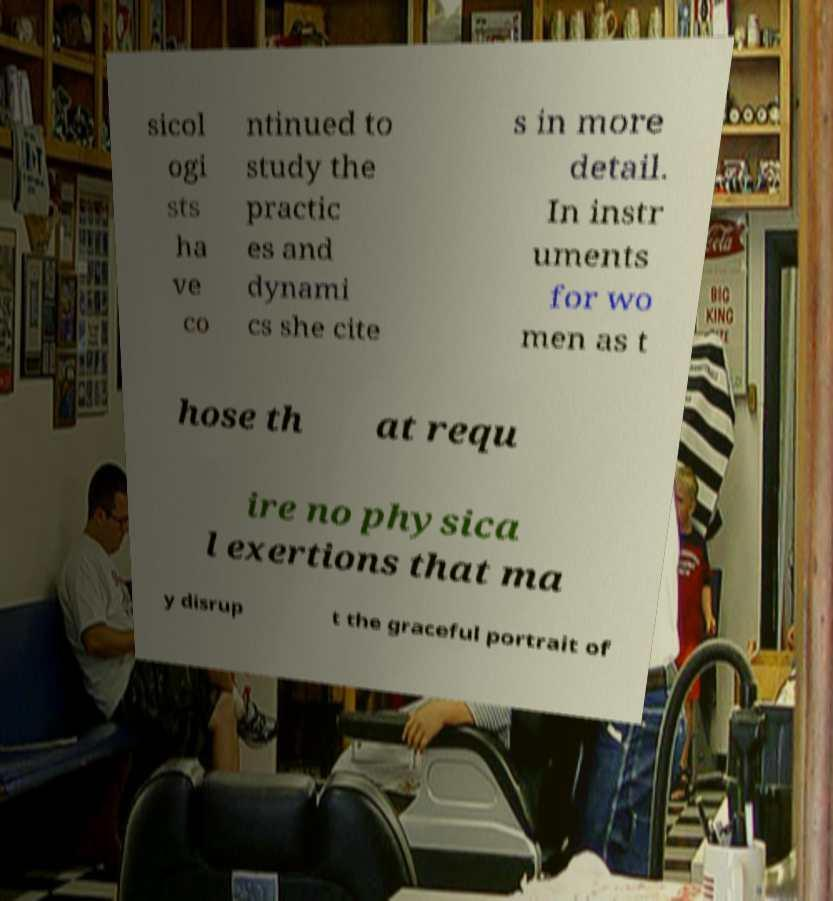I need the written content from this picture converted into text. Can you do that? sicol ogi sts ha ve co ntinued to study the practic es and dynami cs she cite s in more detail. In instr uments for wo men as t hose th at requ ire no physica l exertions that ma y disrup t the graceful portrait of 